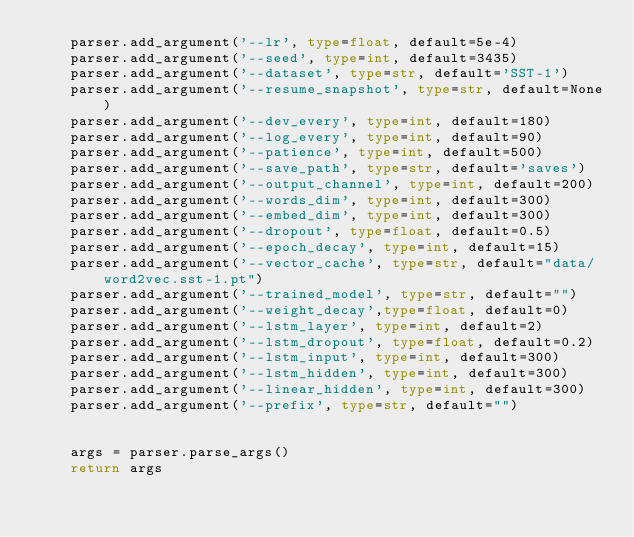<code> <loc_0><loc_0><loc_500><loc_500><_Python_>    parser.add_argument('--lr', type=float, default=5e-4)
    parser.add_argument('--seed', type=int, default=3435)
    parser.add_argument('--dataset', type=str, default='SST-1')
    parser.add_argument('--resume_snapshot', type=str, default=None)
    parser.add_argument('--dev_every', type=int, default=180)
    parser.add_argument('--log_every', type=int, default=90)
    parser.add_argument('--patience', type=int, default=500)
    parser.add_argument('--save_path', type=str, default='saves')
    parser.add_argument('--output_channel', type=int, default=200)
    parser.add_argument('--words_dim', type=int, default=300)
    parser.add_argument('--embed_dim', type=int, default=300)
    parser.add_argument('--dropout', type=float, default=0.5)
    parser.add_argument('--epoch_decay', type=int, default=15)
    parser.add_argument('--vector_cache', type=str, default="data/word2vec.sst-1.pt")
    parser.add_argument('--trained_model', type=str, default="")
    parser.add_argument('--weight_decay',type=float, default=0)
    parser.add_argument('--lstm_layer', type=int, default=2)
    parser.add_argument('--lstm_dropout', type=float, default=0.2)
    parser.add_argument('--lstm_input', type=int, default=300)
    parser.add_argument('--lstm_hidden', type=int, default=300)
    parser.add_argument('--linear_hidden', type=int, default=300)
    parser.add_argument('--prefix', type=str, default="")


    args = parser.parse_args()
    return args
</code> 